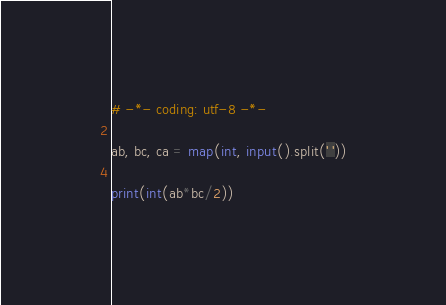<code> <loc_0><loc_0><loc_500><loc_500><_Python_># -*- coding: utf-8 -*-

ab, bc, ca = map(int, input().split(' '))

print(int(ab*bc/2))</code> 